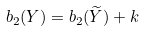Convert formula to latex. <formula><loc_0><loc_0><loc_500><loc_500>b _ { 2 } ( Y ) = b _ { 2 } ( \widetilde { Y } ) + k</formula> 